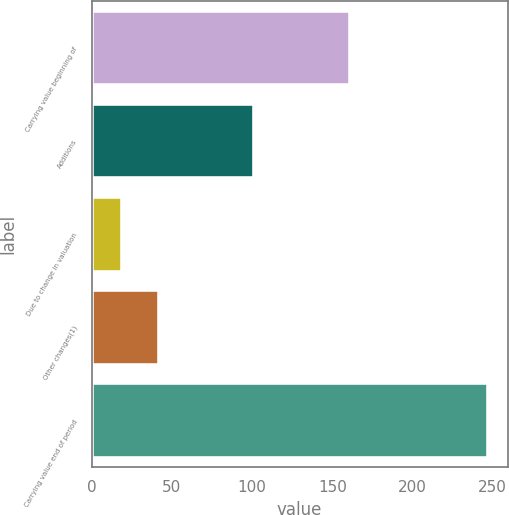<chart> <loc_0><loc_0><loc_500><loc_500><bar_chart><fcel>Carrying value beginning of<fcel>Additions<fcel>Due to change in valuation<fcel>Other changes(1)<fcel>Carrying value end of period<nl><fcel>161<fcel>101<fcel>19<fcel>41.8<fcel>247<nl></chart> 